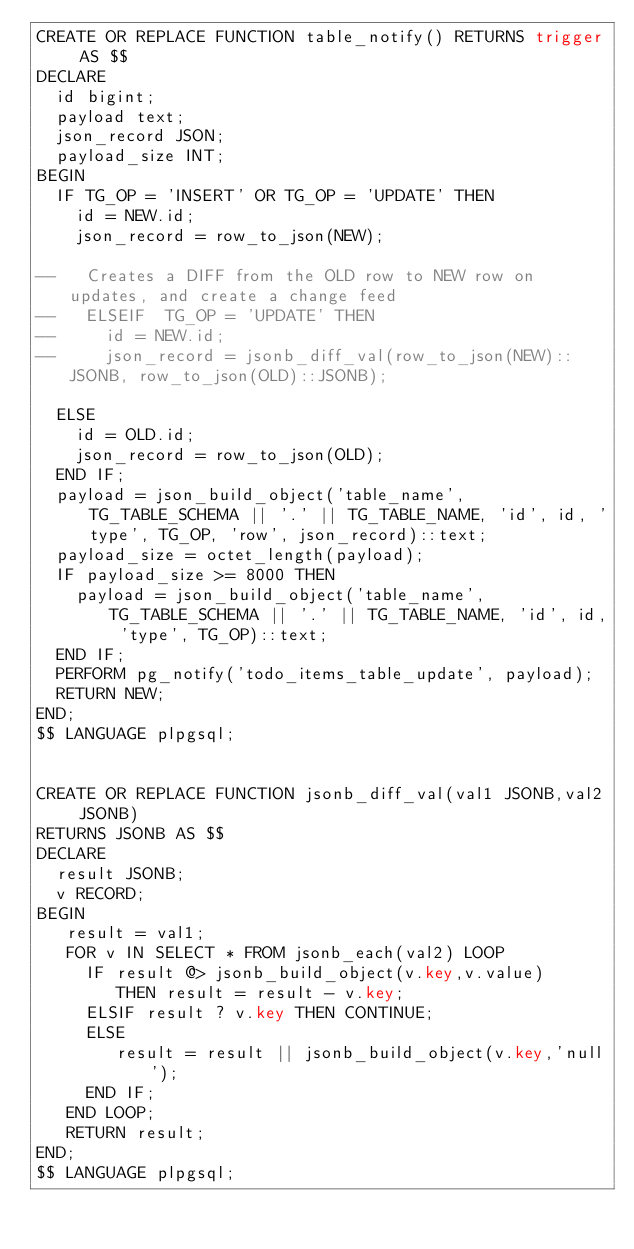Convert code to text. <code><loc_0><loc_0><loc_500><loc_500><_SQL_>CREATE OR REPLACE FUNCTION table_notify() RETURNS trigger AS $$
DECLARE
  id bigint;
  payload text;
  json_record JSON;
  payload_size INT;
BEGIN
  IF TG_OP = 'INSERT' OR TG_OP = 'UPDATE' THEN
    id = NEW.id;
    json_record = row_to_json(NEW);

--   Creates a DIFF from the OLD row to NEW row on updates, and create a change feed
--   ELSEIF  TG_OP = 'UPDATE' THEN
--     id = NEW.id;
--     json_record = jsonb_diff_val(row_to_json(NEW)::JSONB, row_to_json(OLD)::JSONB);

  ELSE
    id = OLD.id;
    json_record = row_to_json(OLD);
  END IF;
  payload = json_build_object('table_name', TG_TABLE_SCHEMA || '.' || TG_TABLE_NAME, 'id', id, 'type', TG_OP, 'row', json_record)::text;
  payload_size = octet_length(payload);
  IF payload_size >= 8000 THEN
    payload = json_build_object('table_name', TG_TABLE_SCHEMA || '.' || TG_TABLE_NAME, 'id', id, 'type', TG_OP)::text;
  END IF;
  PERFORM pg_notify('todo_items_table_update', payload);
  RETURN NEW;
END;
$$ LANGUAGE plpgsql;


CREATE OR REPLACE FUNCTION jsonb_diff_val(val1 JSONB,val2 JSONB)
RETURNS JSONB AS $$
DECLARE
  result JSONB;
  v RECORD;
BEGIN
   result = val1;
   FOR v IN SELECT * FROM jsonb_each(val2) LOOP
     IF result @> jsonb_build_object(v.key,v.value)
        THEN result = result - v.key;
     ELSIF result ? v.key THEN CONTINUE;
     ELSE
        result = result || jsonb_build_object(v.key,'null');
     END IF;
   END LOOP;
   RETURN result;
END;
$$ LANGUAGE plpgsql;
</code> 